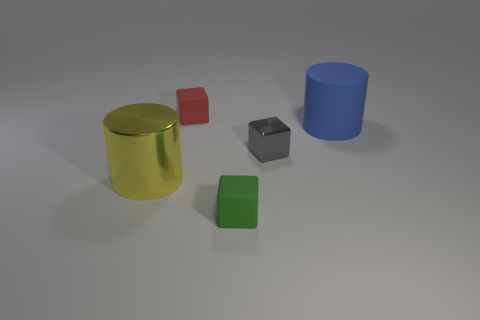How many other small things have the same material as the small green object?
Make the answer very short. 1. There is a matte object in front of the blue thing; does it have the same size as the cylinder that is left of the green rubber cube?
Offer a very short reply. No. The small thing on the left side of the tiny rubber thing that is in front of the big blue matte cylinder is made of what material?
Your answer should be compact. Rubber. Is the number of gray metal things on the left side of the small gray metallic cube less than the number of large yellow objects left of the blue rubber cylinder?
Your answer should be very brief. Yes. Is there anything else that is the same shape as the large blue thing?
Your answer should be compact. Yes. What is the material of the large cylinder to the right of the large metal cylinder?
Provide a short and direct response. Rubber. Is there any other thing that is the same size as the gray metallic block?
Your answer should be very brief. Yes. There is a tiny gray metal object; are there any small gray blocks behind it?
Provide a succinct answer. No. What is the shape of the small green rubber thing?
Your answer should be very brief. Cube. What number of things are big cylinders that are to the left of the small green thing or green rubber things?
Ensure brevity in your answer.  2. 